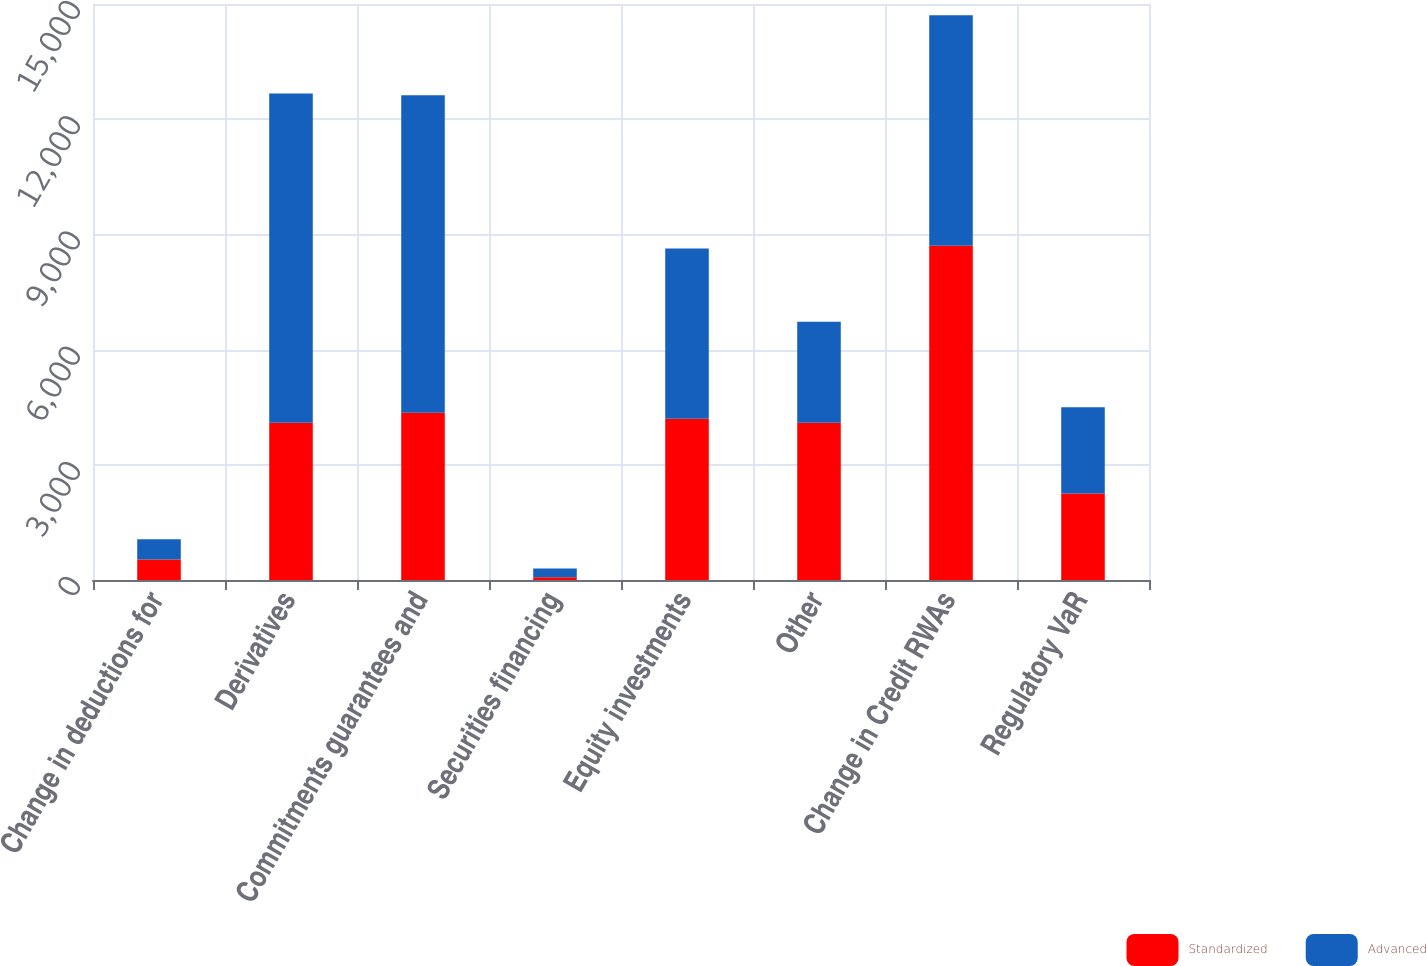<chart> <loc_0><loc_0><loc_500><loc_500><stacked_bar_chart><ecel><fcel>Change in deductions for<fcel>Derivatives<fcel>Commitments guarantees and<fcel>Securities financing<fcel>Equity investments<fcel>Other<fcel>Change in Credit RWAs<fcel>Regulatory VaR<nl><fcel>Standardized<fcel>531<fcel>4095<fcel>4353<fcel>73<fcel>4196<fcel>4095<fcel>8705<fcel>2250<nl><fcel>Advanced<fcel>531<fcel>8575<fcel>8269<fcel>228<fcel>4440<fcel>2630<fcel>6005<fcel>2250<nl></chart> 